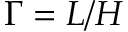Convert formula to latex. <formula><loc_0><loc_0><loc_500><loc_500>\Gamma = L / H</formula> 